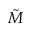Convert formula to latex. <formula><loc_0><loc_0><loc_500><loc_500>\tilde { M }</formula> 